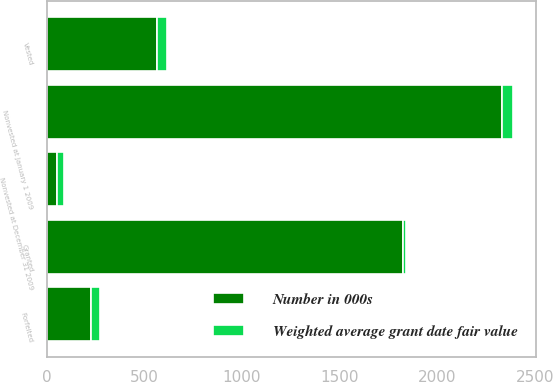<chart> <loc_0><loc_0><loc_500><loc_500><stacked_bar_chart><ecel><fcel>Nonvested at January 1 2009<fcel>Granted<fcel>Vested<fcel>Forfeited<fcel>Nonvested at December 31 2009<nl><fcel>Number in 000s<fcel>2332<fcel>1823<fcel>563<fcel>224<fcel>53.97<nl><fcel>Weighted average grant date fair value<fcel>53.97<fcel>17.47<fcel>52.99<fcel>47.16<fcel>34.83<nl></chart> 